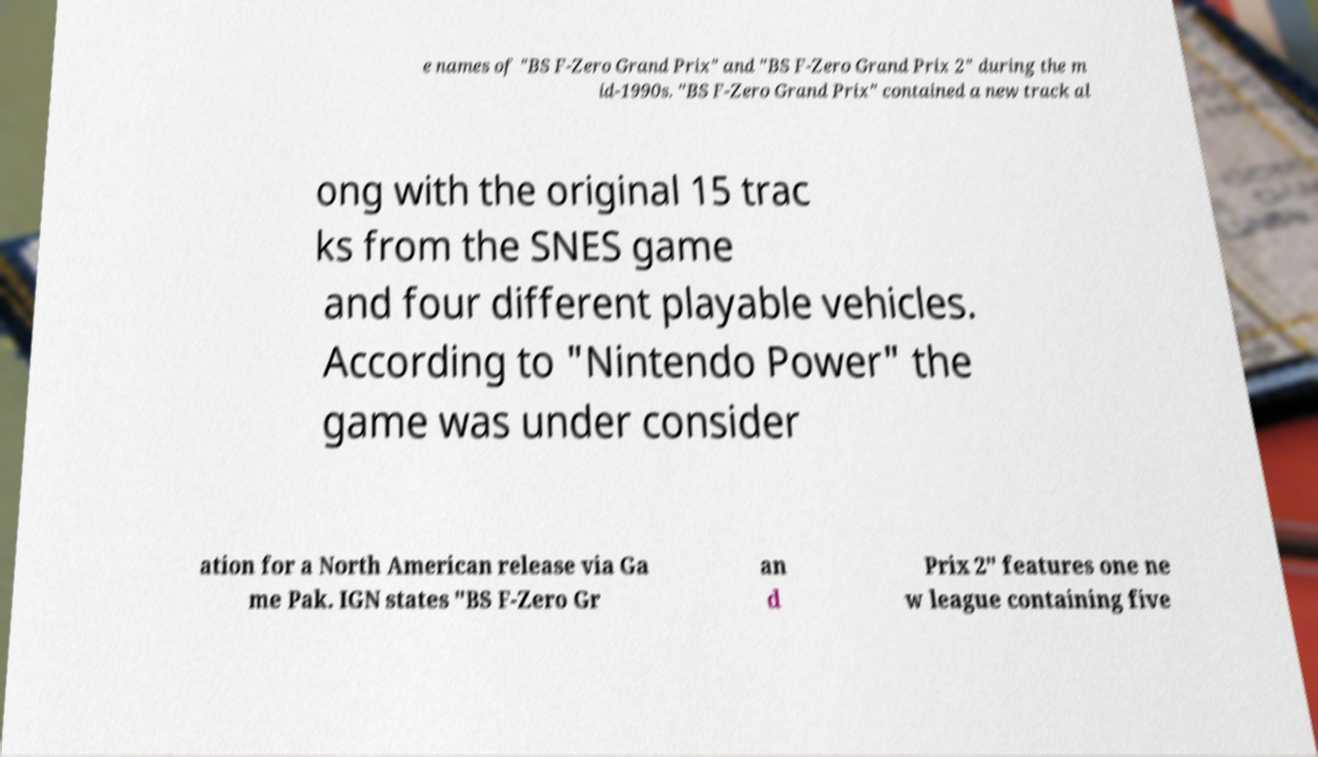For documentation purposes, I need the text within this image transcribed. Could you provide that? e names of "BS F-Zero Grand Prix" and "BS F-Zero Grand Prix 2" during the m id-1990s. "BS F-Zero Grand Prix" contained a new track al ong with the original 15 trac ks from the SNES game and four different playable vehicles. According to "Nintendo Power" the game was under consider ation for a North American release via Ga me Pak. IGN states "BS F-Zero Gr an d Prix 2" features one ne w league containing five 